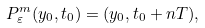Convert formula to latex. <formula><loc_0><loc_0><loc_500><loc_500>P ^ { m } _ { \varepsilon } ( y _ { 0 } , t _ { 0 } ) = ( y _ { 0 } , t _ { 0 } + n T ) ,</formula> 